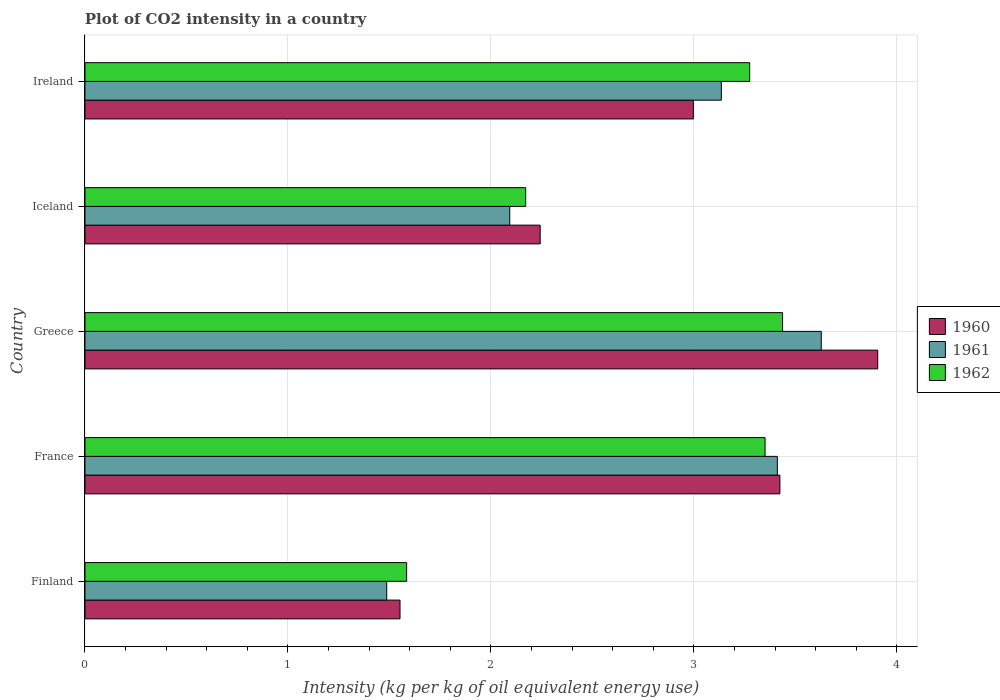How many groups of bars are there?
Give a very brief answer. 5. Are the number of bars per tick equal to the number of legend labels?
Your answer should be very brief. Yes. How many bars are there on the 4th tick from the top?
Keep it short and to the point. 3. How many bars are there on the 3rd tick from the bottom?
Your answer should be compact. 3. What is the label of the 4th group of bars from the top?
Provide a short and direct response. France. In how many cases, is the number of bars for a given country not equal to the number of legend labels?
Your response must be concise. 0. What is the CO2 intensity in in 1962 in Finland?
Offer a very short reply. 1.58. Across all countries, what is the maximum CO2 intensity in in 1961?
Provide a succinct answer. 3.63. Across all countries, what is the minimum CO2 intensity in in 1962?
Your answer should be compact. 1.58. In which country was the CO2 intensity in in 1961 maximum?
Make the answer very short. Greece. In which country was the CO2 intensity in in 1960 minimum?
Your answer should be very brief. Finland. What is the total CO2 intensity in in 1962 in the graph?
Make the answer very short. 13.82. What is the difference between the CO2 intensity in in 1962 in Finland and that in Ireland?
Your response must be concise. -1.69. What is the difference between the CO2 intensity in in 1962 in Greece and the CO2 intensity in in 1961 in Finland?
Your answer should be very brief. 1.95. What is the average CO2 intensity in in 1962 per country?
Give a very brief answer. 2.76. What is the difference between the CO2 intensity in in 1962 and CO2 intensity in in 1960 in Ireland?
Make the answer very short. 0.28. In how many countries, is the CO2 intensity in in 1961 greater than 1.8 kg?
Offer a terse response. 4. What is the ratio of the CO2 intensity in in 1961 in Iceland to that in Ireland?
Offer a terse response. 0.67. What is the difference between the highest and the second highest CO2 intensity in in 1962?
Your response must be concise. 0.09. What is the difference between the highest and the lowest CO2 intensity in in 1962?
Offer a terse response. 1.85. Is the sum of the CO2 intensity in in 1960 in Finland and France greater than the maximum CO2 intensity in in 1961 across all countries?
Ensure brevity in your answer.  Yes. What does the 3rd bar from the top in Ireland represents?
Keep it short and to the point. 1960. What does the 2nd bar from the bottom in Greece represents?
Make the answer very short. 1961. How many bars are there?
Your response must be concise. 15. What is the difference between two consecutive major ticks on the X-axis?
Give a very brief answer. 1. Are the values on the major ticks of X-axis written in scientific E-notation?
Ensure brevity in your answer.  No. Does the graph contain grids?
Your answer should be compact. Yes. Where does the legend appear in the graph?
Your answer should be very brief. Center right. How many legend labels are there?
Provide a short and direct response. 3. How are the legend labels stacked?
Your answer should be very brief. Vertical. What is the title of the graph?
Make the answer very short. Plot of CO2 intensity in a country. What is the label or title of the X-axis?
Provide a succinct answer. Intensity (kg per kg of oil equivalent energy use). What is the Intensity (kg per kg of oil equivalent energy use) in 1960 in Finland?
Provide a succinct answer. 1.55. What is the Intensity (kg per kg of oil equivalent energy use) in 1961 in Finland?
Offer a very short reply. 1.49. What is the Intensity (kg per kg of oil equivalent energy use) of 1962 in Finland?
Give a very brief answer. 1.58. What is the Intensity (kg per kg of oil equivalent energy use) in 1960 in France?
Make the answer very short. 3.42. What is the Intensity (kg per kg of oil equivalent energy use) in 1961 in France?
Provide a short and direct response. 3.41. What is the Intensity (kg per kg of oil equivalent energy use) of 1962 in France?
Your response must be concise. 3.35. What is the Intensity (kg per kg of oil equivalent energy use) in 1960 in Greece?
Your answer should be very brief. 3.91. What is the Intensity (kg per kg of oil equivalent energy use) of 1961 in Greece?
Keep it short and to the point. 3.63. What is the Intensity (kg per kg of oil equivalent energy use) in 1962 in Greece?
Make the answer very short. 3.44. What is the Intensity (kg per kg of oil equivalent energy use) of 1960 in Iceland?
Your answer should be very brief. 2.24. What is the Intensity (kg per kg of oil equivalent energy use) in 1961 in Iceland?
Offer a terse response. 2.09. What is the Intensity (kg per kg of oil equivalent energy use) of 1962 in Iceland?
Make the answer very short. 2.17. What is the Intensity (kg per kg of oil equivalent energy use) in 1960 in Ireland?
Offer a terse response. 3. What is the Intensity (kg per kg of oil equivalent energy use) in 1961 in Ireland?
Your answer should be very brief. 3.14. What is the Intensity (kg per kg of oil equivalent energy use) in 1962 in Ireland?
Your answer should be very brief. 3.27. Across all countries, what is the maximum Intensity (kg per kg of oil equivalent energy use) in 1960?
Your answer should be compact. 3.91. Across all countries, what is the maximum Intensity (kg per kg of oil equivalent energy use) in 1961?
Make the answer very short. 3.63. Across all countries, what is the maximum Intensity (kg per kg of oil equivalent energy use) of 1962?
Provide a succinct answer. 3.44. Across all countries, what is the minimum Intensity (kg per kg of oil equivalent energy use) of 1960?
Your answer should be very brief. 1.55. Across all countries, what is the minimum Intensity (kg per kg of oil equivalent energy use) in 1961?
Your answer should be very brief. 1.49. Across all countries, what is the minimum Intensity (kg per kg of oil equivalent energy use) of 1962?
Keep it short and to the point. 1.58. What is the total Intensity (kg per kg of oil equivalent energy use) of 1960 in the graph?
Offer a terse response. 14.12. What is the total Intensity (kg per kg of oil equivalent energy use) of 1961 in the graph?
Provide a succinct answer. 13.75. What is the total Intensity (kg per kg of oil equivalent energy use) in 1962 in the graph?
Your answer should be compact. 13.82. What is the difference between the Intensity (kg per kg of oil equivalent energy use) in 1960 in Finland and that in France?
Offer a very short reply. -1.87. What is the difference between the Intensity (kg per kg of oil equivalent energy use) of 1961 in Finland and that in France?
Ensure brevity in your answer.  -1.92. What is the difference between the Intensity (kg per kg of oil equivalent energy use) in 1962 in Finland and that in France?
Provide a short and direct response. -1.77. What is the difference between the Intensity (kg per kg of oil equivalent energy use) of 1960 in Finland and that in Greece?
Your answer should be very brief. -2.35. What is the difference between the Intensity (kg per kg of oil equivalent energy use) in 1961 in Finland and that in Greece?
Provide a short and direct response. -2.14. What is the difference between the Intensity (kg per kg of oil equivalent energy use) of 1962 in Finland and that in Greece?
Give a very brief answer. -1.85. What is the difference between the Intensity (kg per kg of oil equivalent energy use) of 1960 in Finland and that in Iceland?
Offer a very short reply. -0.69. What is the difference between the Intensity (kg per kg of oil equivalent energy use) in 1961 in Finland and that in Iceland?
Give a very brief answer. -0.61. What is the difference between the Intensity (kg per kg of oil equivalent energy use) of 1962 in Finland and that in Iceland?
Offer a terse response. -0.59. What is the difference between the Intensity (kg per kg of oil equivalent energy use) in 1960 in Finland and that in Ireland?
Offer a very short reply. -1.45. What is the difference between the Intensity (kg per kg of oil equivalent energy use) of 1961 in Finland and that in Ireland?
Offer a very short reply. -1.65. What is the difference between the Intensity (kg per kg of oil equivalent energy use) of 1962 in Finland and that in Ireland?
Keep it short and to the point. -1.69. What is the difference between the Intensity (kg per kg of oil equivalent energy use) of 1960 in France and that in Greece?
Give a very brief answer. -0.48. What is the difference between the Intensity (kg per kg of oil equivalent energy use) of 1961 in France and that in Greece?
Keep it short and to the point. -0.22. What is the difference between the Intensity (kg per kg of oil equivalent energy use) in 1962 in France and that in Greece?
Offer a terse response. -0.09. What is the difference between the Intensity (kg per kg of oil equivalent energy use) in 1960 in France and that in Iceland?
Provide a succinct answer. 1.18. What is the difference between the Intensity (kg per kg of oil equivalent energy use) in 1961 in France and that in Iceland?
Provide a succinct answer. 1.32. What is the difference between the Intensity (kg per kg of oil equivalent energy use) in 1962 in France and that in Iceland?
Give a very brief answer. 1.18. What is the difference between the Intensity (kg per kg of oil equivalent energy use) of 1960 in France and that in Ireland?
Offer a terse response. 0.43. What is the difference between the Intensity (kg per kg of oil equivalent energy use) in 1961 in France and that in Ireland?
Provide a succinct answer. 0.28. What is the difference between the Intensity (kg per kg of oil equivalent energy use) in 1962 in France and that in Ireland?
Make the answer very short. 0.08. What is the difference between the Intensity (kg per kg of oil equivalent energy use) of 1960 in Greece and that in Iceland?
Give a very brief answer. 1.66. What is the difference between the Intensity (kg per kg of oil equivalent energy use) in 1961 in Greece and that in Iceland?
Make the answer very short. 1.53. What is the difference between the Intensity (kg per kg of oil equivalent energy use) in 1962 in Greece and that in Iceland?
Offer a very short reply. 1.27. What is the difference between the Intensity (kg per kg of oil equivalent energy use) of 1960 in Greece and that in Ireland?
Give a very brief answer. 0.91. What is the difference between the Intensity (kg per kg of oil equivalent energy use) in 1961 in Greece and that in Ireland?
Offer a very short reply. 0.49. What is the difference between the Intensity (kg per kg of oil equivalent energy use) of 1962 in Greece and that in Ireland?
Your response must be concise. 0.16. What is the difference between the Intensity (kg per kg of oil equivalent energy use) of 1960 in Iceland and that in Ireland?
Offer a very short reply. -0.75. What is the difference between the Intensity (kg per kg of oil equivalent energy use) in 1961 in Iceland and that in Ireland?
Offer a very short reply. -1.04. What is the difference between the Intensity (kg per kg of oil equivalent energy use) of 1962 in Iceland and that in Ireland?
Provide a short and direct response. -1.1. What is the difference between the Intensity (kg per kg of oil equivalent energy use) of 1960 in Finland and the Intensity (kg per kg of oil equivalent energy use) of 1961 in France?
Offer a very short reply. -1.86. What is the difference between the Intensity (kg per kg of oil equivalent energy use) of 1960 in Finland and the Intensity (kg per kg of oil equivalent energy use) of 1962 in France?
Offer a very short reply. -1.8. What is the difference between the Intensity (kg per kg of oil equivalent energy use) of 1961 in Finland and the Intensity (kg per kg of oil equivalent energy use) of 1962 in France?
Offer a very short reply. -1.86. What is the difference between the Intensity (kg per kg of oil equivalent energy use) in 1960 in Finland and the Intensity (kg per kg of oil equivalent energy use) in 1961 in Greece?
Offer a very short reply. -2.08. What is the difference between the Intensity (kg per kg of oil equivalent energy use) of 1960 in Finland and the Intensity (kg per kg of oil equivalent energy use) of 1962 in Greece?
Ensure brevity in your answer.  -1.88. What is the difference between the Intensity (kg per kg of oil equivalent energy use) of 1961 in Finland and the Intensity (kg per kg of oil equivalent energy use) of 1962 in Greece?
Ensure brevity in your answer.  -1.95. What is the difference between the Intensity (kg per kg of oil equivalent energy use) in 1960 in Finland and the Intensity (kg per kg of oil equivalent energy use) in 1961 in Iceland?
Your answer should be very brief. -0.54. What is the difference between the Intensity (kg per kg of oil equivalent energy use) of 1960 in Finland and the Intensity (kg per kg of oil equivalent energy use) of 1962 in Iceland?
Make the answer very short. -0.62. What is the difference between the Intensity (kg per kg of oil equivalent energy use) of 1961 in Finland and the Intensity (kg per kg of oil equivalent energy use) of 1962 in Iceland?
Your answer should be very brief. -0.68. What is the difference between the Intensity (kg per kg of oil equivalent energy use) of 1960 in Finland and the Intensity (kg per kg of oil equivalent energy use) of 1961 in Ireland?
Offer a very short reply. -1.58. What is the difference between the Intensity (kg per kg of oil equivalent energy use) in 1960 in Finland and the Intensity (kg per kg of oil equivalent energy use) in 1962 in Ireland?
Provide a succinct answer. -1.72. What is the difference between the Intensity (kg per kg of oil equivalent energy use) in 1961 in Finland and the Intensity (kg per kg of oil equivalent energy use) in 1962 in Ireland?
Keep it short and to the point. -1.79. What is the difference between the Intensity (kg per kg of oil equivalent energy use) in 1960 in France and the Intensity (kg per kg of oil equivalent energy use) in 1961 in Greece?
Ensure brevity in your answer.  -0.2. What is the difference between the Intensity (kg per kg of oil equivalent energy use) in 1960 in France and the Intensity (kg per kg of oil equivalent energy use) in 1962 in Greece?
Your answer should be compact. -0.01. What is the difference between the Intensity (kg per kg of oil equivalent energy use) in 1961 in France and the Intensity (kg per kg of oil equivalent energy use) in 1962 in Greece?
Give a very brief answer. -0.03. What is the difference between the Intensity (kg per kg of oil equivalent energy use) of 1960 in France and the Intensity (kg per kg of oil equivalent energy use) of 1961 in Iceland?
Provide a short and direct response. 1.33. What is the difference between the Intensity (kg per kg of oil equivalent energy use) in 1960 in France and the Intensity (kg per kg of oil equivalent energy use) in 1962 in Iceland?
Provide a succinct answer. 1.25. What is the difference between the Intensity (kg per kg of oil equivalent energy use) in 1961 in France and the Intensity (kg per kg of oil equivalent energy use) in 1962 in Iceland?
Give a very brief answer. 1.24. What is the difference between the Intensity (kg per kg of oil equivalent energy use) in 1960 in France and the Intensity (kg per kg of oil equivalent energy use) in 1961 in Ireland?
Your answer should be compact. 0.29. What is the difference between the Intensity (kg per kg of oil equivalent energy use) in 1960 in France and the Intensity (kg per kg of oil equivalent energy use) in 1962 in Ireland?
Offer a very short reply. 0.15. What is the difference between the Intensity (kg per kg of oil equivalent energy use) in 1961 in France and the Intensity (kg per kg of oil equivalent energy use) in 1962 in Ireland?
Keep it short and to the point. 0.14. What is the difference between the Intensity (kg per kg of oil equivalent energy use) in 1960 in Greece and the Intensity (kg per kg of oil equivalent energy use) in 1961 in Iceland?
Offer a terse response. 1.81. What is the difference between the Intensity (kg per kg of oil equivalent energy use) in 1960 in Greece and the Intensity (kg per kg of oil equivalent energy use) in 1962 in Iceland?
Your response must be concise. 1.73. What is the difference between the Intensity (kg per kg of oil equivalent energy use) in 1961 in Greece and the Intensity (kg per kg of oil equivalent energy use) in 1962 in Iceland?
Give a very brief answer. 1.46. What is the difference between the Intensity (kg per kg of oil equivalent energy use) of 1960 in Greece and the Intensity (kg per kg of oil equivalent energy use) of 1961 in Ireland?
Your response must be concise. 0.77. What is the difference between the Intensity (kg per kg of oil equivalent energy use) in 1960 in Greece and the Intensity (kg per kg of oil equivalent energy use) in 1962 in Ireland?
Offer a very short reply. 0.63. What is the difference between the Intensity (kg per kg of oil equivalent energy use) in 1961 in Greece and the Intensity (kg per kg of oil equivalent energy use) in 1962 in Ireland?
Offer a terse response. 0.35. What is the difference between the Intensity (kg per kg of oil equivalent energy use) in 1960 in Iceland and the Intensity (kg per kg of oil equivalent energy use) in 1961 in Ireland?
Give a very brief answer. -0.89. What is the difference between the Intensity (kg per kg of oil equivalent energy use) in 1960 in Iceland and the Intensity (kg per kg of oil equivalent energy use) in 1962 in Ireland?
Your answer should be very brief. -1.03. What is the difference between the Intensity (kg per kg of oil equivalent energy use) in 1961 in Iceland and the Intensity (kg per kg of oil equivalent energy use) in 1962 in Ireland?
Give a very brief answer. -1.18. What is the average Intensity (kg per kg of oil equivalent energy use) in 1960 per country?
Offer a very short reply. 2.82. What is the average Intensity (kg per kg of oil equivalent energy use) of 1961 per country?
Offer a terse response. 2.75. What is the average Intensity (kg per kg of oil equivalent energy use) of 1962 per country?
Ensure brevity in your answer.  2.76. What is the difference between the Intensity (kg per kg of oil equivalent energy use) in 1960 and Intensity (kg per kg of oil equivalent energy use) in 1961 in Finland?
Provide a short and direct response. 0.07. What is the difference between the Intensity (kg per kg of oil equivalent energy use) in 1960 and Intensity (kg per kg of oil equivalent energy use) in 1962 in Finland?
Your answer should be compact. -0.03. What is the difference between the Intensity (kg per kg of oil equivalent energy use) of 1961 and Intensity (kg per kg of oil equivalent energy use) of 1962 in Finland?
Your response must be concise. -0.1. What is the difference between the Intensity (kg per kg of oil equivalent energy use) of 1960 and Intensity (kg per kg of oil equivalent energy use) of 1961 in France?
Provide a succinct answer. 0.01. What is the difference between the Intensity (kg per kg of oil equivalent energy use) in 1960 and Intensity (kg per kg of oil equivalent energy use) in 1962 in France?
Ensure brevity in your answer.  0.07. What is the difference between the Intensity (kg per kg of oil equivalent energy use) of 1961 and Intensity (kg per kg of oil equivalent energy use) of 1962 in France?
Keep it short and to the point. 0.06. What is the difference between the Intensity (kg per kg of oil equivalent energy use) in 1960 and Intensity (kg per kg of oil equivalent energy use) in 1961 in Greece?
Offer a terse response. 0.28. What is the difference between the Intensity (kg per kg of oil equivalent energy use) in 1960 and Intensity (kg per kg of oil equivalent energy use) in 1962 in Greece?
Your answer should be compact. 0.47. What is the difference between the Intensity (kg per kg of oil equivalent energy use) of 1961 and Intensity (kg per kg of oil equivalent energy use) of 1962 in Greece?
Provide a short and direct response. 0.19. What is the difference between the Intensity (kg per kg of oil equivalent energy use) of 1960 and Intensity (kg per kg of oil equivalent energy use) of 1961 in Iceland?
Offer a very short reply. 0.15. What is the difference between the Intensity (kg per kg of oil equivalent energy use) in 1960 and Intensity (kg per kg of oil equivalent energy use) in 1962 in Iceland?
Your response must be concise. 0.07. What is the difference between the Intensity (kg per kg of oil equivalent energy use) in 1961 and Intensity (kg per kg of oil equivalent energy use) in 1962 in Iceland?
Make the answer very short. -0.08. What is the difference between the Intensity (kg per kg of oil equivalent energy use) of 1960 and Intensity (kg per kg of oil equivalent energy use) of 1961 in Ireland?
Your answer should be very brief. -0.14. What is the difference between the Intensity (kg per kg of oil equivalent energy use) of 1960 and Intensity (kg per kg of oil equivalent energy use) of 1962 in Ireland?
Your response must be concise. -0.28. What is the difference between the Intensity (kg per kg of oil equivalent energy use) in 1961 and Intensity (kg per kg of oil equivalent energy use) in 1962 in Ireland?
Ensure brevity in your answer.  -0.14. What is the ratio of the Intensity (kg per kg of oil equivalent energy use) of 1960 in Finland to that in France?
Offer a terse response. 0.45. What is the ratio of the Intensity (kg per kg of oil equivalent energy use) in 1961 in Finland to that in France?
Give a very brief answer. 0.44. What is the ratio of the Intensity (kg per kg of oil equivalent energy use) of 1962 in Finland to that in France?
Offer a very short reply. 0.47. What is the ratio of the Intensity (kg per kg of oil equivalent energy use) in 1960 in Finland to that in Greece?
Your response must be concise. 0.4. What is the ratio of the Intensity (kg per kg of oil equivalent energy use) of 1961 in Finland to that in Greece?
Make the answer very short. 0.41. What is the ratio of the Intensity (kg per kg of oil equivalent energy use) in 1962 in Finland to that in Greece?
Keep it short and to the point. 0.46. What is the ratio of the Intensity (kg per kg of oil equivalent energy use) in 1960 in Finland to that in Iceland?
Your response must be concise. 0.69. What is the ratio of the Intensity (kg per kg of oil equivalent energy use) of 1961 in Finland to that in Iceland?
Make the answer very short. 0.71. What is the ratio of the Intensity (kg per kg of oil equivalent energy use) of 1962 in Finland to that in Iceland?
Offer a terse response. 0.73. What is the ratio of the Intensity (kg per kg of oil equivalent energy use) of 1960 in Finland to that in Ireland?
Your answer should be very brief. 0.52. What is the ratio of the Intensity (kg per kg of oil equivalent energy use) in 1961 in Finland to that in Ireland?
Offer a very short reply. 0.47. What is the ratio of the Intensity (kg per kg of oil equivalent energy use) in 1962 in Finland to that in Ireland?
Give a very brief answer. 0.48. What is the ratio of the Intensity (kg per kg of oil equivalent energy use) of 1960 in France to that in Greece?
Provide a short and direct response. 0.88. What is the ratio of the Intensity (kg per kg of oil equivalent energy use) of 1961 in France to that in Greece?
Ensure brevity in your answer.  0.94. What is the ratio of the Intensity (kg per kg of oil equivalent energy use) of 1962 in France to that in Greece?
Your answer should be very brief. 0.97. What is the ratio of the Intensity (kg per kg of oil equivalent energy use) of 1960 in France to that in Iceland?
Provide a short and direct response. 1.53. What is the ratio of the Intensity (kg per kg of oil equivalent energy use) in 1961 in France to that in Iceland?
Provide a short and direct response. 1.63. What is the ratio of the Intensity (kg per kg of oil equivalent energy use) in 1962 in France to that in Iceland?
Your response must be concise. 1.54. What is the ratio of the Intensity (kg per kg of oil equivalent energy use) of 1960 in France to that in Ireland?
Make the answer very short. 1.14. What is the ratio of the Intensity (kg per kg of oil equivalent energy use) of 1961 in France to that in Ireland?
Your answer should be very brief. 1.09. What is the ratio of the Intensity (kg per kg of oil equivalent energy use) in 1962 in France to that in Ireland?
Your response must be concise. 1.02. What is the ratio of the Intensity (kg per kg of oil equivalent energy use) of 1960 in Greece to that in Iceland?
Your answer should be compact. 1.74. What is the ratio of the Intensity (kg per kg of oil equivalent energy use) in 1961 in Greece to that in Iceland?
Your answer should be very brief. 1.73. What is the ratio of the Intensity (kg per kg of oil equivalent energy use) of 1962 in Greece to that in Iceland?
Provide a succinct answer. 1.58. What is the ratio of the Intensity (kg per kg of oil equivalent energy use) in 1960 in Greece to that in Ireland?
Make the answer very short. 1.3. What is the ratio of the Intensity (kg per kg of oil equivalent energy use) in 1961 in Greece to that in Ireland?
Your answer should be compact. 1.16. What is the ratio of the Intensity (kg per kg of oil equivalent energy use) in 1962 in Greece to that in Ireland?
Keep it short and to the point. 1.05. What is the ratio of the Intensity (kg per kg of oil equivalent energy use) of 1960 in Iceland to that in Ireland?
Offer a very short reply. 0.75. What is the ratio of the Intensity (kg per kg of oil equivalent energy use) of 1961 in Iceland to that in Ireland?
Your answer should be compact. 0.67. What is the ratio of the Intensity (kg per kg of oil equivalent energy use) in 1962 in Iceland to that in Ireland?
Provide a short and direct response. 0.66. What is the difference between the highest and the second highest Intensity (kg per kg of oil equivalent energy use) in 1960?
Provide a succinct answer. 0.48. What is the difference between the highest and the second highest Intensity (kg per kg of oil equivalent energy use) in 1961?
Your answer should be compact. 0.22. What is the difference between the highest and the second highest Intensity (kg per kg of oil equivalent energy use) in 1962?
Give a very brief answer. 0.09. What is the difference between the highest and the lowest Intensity (kg per kg of oil equivalent energy use) of 1960?
Keep it short and to the point. 2.35. What is the difference between the highest and the lowest Intensity (kg per kg of oil equivalent energy use) in 1961?
Offer a very short reply. 2.14. What is the difference between the highest and the lowest Intensity (kg per kg of oil equivalent energy use) in 1962?
Keep it short and to the point. 1.85. 